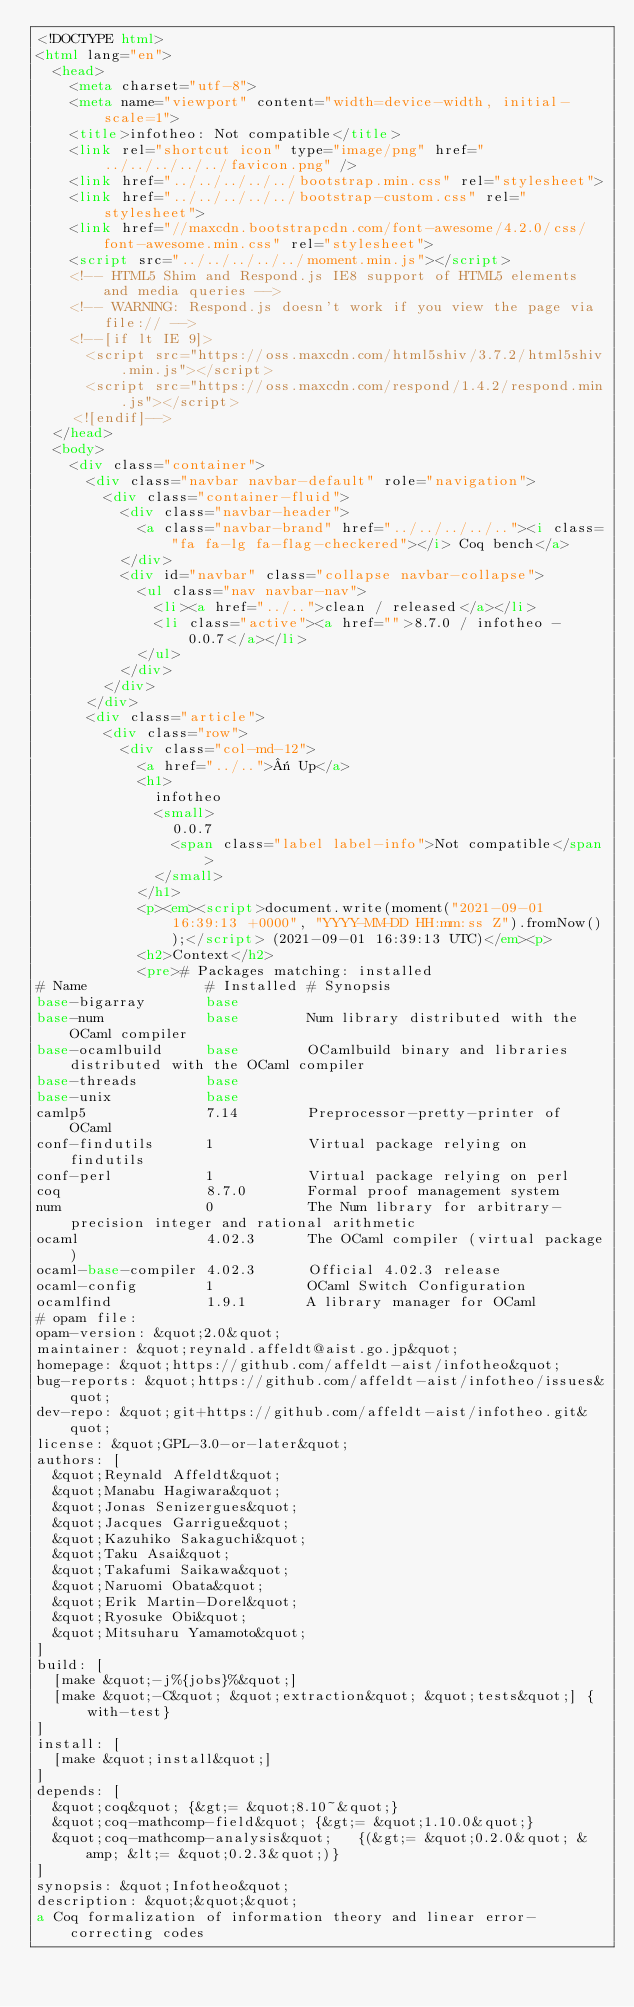<code> <loc_0><loc_0><loc_500><loc_500><_HTML_><!DOCTYPE html>
<html lang="en">
  <head>
    <meta charset="utf-8">
    <meta name="viewport" content="width=device-width, initial-scale=1">
    <title>infotheo: Not compatible</title>
    <link rel="shortcut icon" type="image/png" href="../../../../../favicon.png" />
    <link href="../../../../../bootstrap.min.css" rel="stylesheet">
    <link href="../../../../../bootstrap-custom.css" rel="stylesheet">
    <link href="//maxcdn.bootstrapcdn.com/font-awesome/4.2.0/css/font-awesome.min.css" rel="stylesheet">
    <script src="../../../../../moment.min.js"></script>
    <!-- HTML5 Shim and Respond.js IE8 support of HTML5 elements and media queries -->
    <!-- WARNING: Respond.js doesn't work if you view the page via file:// -->
    <!--[if lt IE 9]>
      <script src="https://oss.maxcdn.com/html5shiv/3.7.2/html5shiv.min.js"></script>
      <script src="https://oss.maxcdn.com/respond/1.4.2/respond.min.js"></script>
    <![endif]-->
  </head>
  <body>
    <div class="container">
      <div class="navbar navbar-default" role="navigation">
        <div class="container-fluid">
          <div class="navbar-header">
            <a class="navbar-brand" href="../../../../.."><i class="fa fa-lg fa-flag-checkered"></i> Coq bench</a>
          </div>
          <div id="navbar" class="collapse navbar-collapse">
            <ul class="nav navbar-nav">
              <li><a href="../..">clean / released</a></li>
              <li class="active"><a href="">8.7.0 / infotheo - 0.0.7</a></li>
            </ul>
          </div>
        </div>
      </div>
      <div class="article">
        <div class="row">
          <div class="col-md-12">
            <a href="../..">« Up</a>
            <h1>
              infotheo
              <small>
                0.0.7
                <span class="label label-info">Not compatible</span>
              </small>
            </h1>
            <p><em><script>document.write(moment("2021-09-01 16:39:13 +0000", "YYYY-MM-DD HH:mm:ss Z").fromNow());</script> (2021-09-01 16:39:13 UTC)</em><p>
            <h2>Context</h2>
            <pre># Packages matching: installed
# Name              # Installed # Synopsis
base-bigarray       base
base-num            base        Num library distributed with the OCaml compiler
base-ocamlbuild     base        OCamlbuild binary and libraries distributed with the OCaml compiler
base-threads        base
base-unix           base
camlp5              7.14        Preprocessor-pretty-printer of OCaml
conf-findutils      1           Virtual package relying on findutils
conf-perl           1           Virtual package relying on perl
coq                 8.7.0       Formal proof management system
num                 0           The Num library for arbitrary-precision integer and rational arithmetic
ocaml               4.02.3      The OCaml compiler (virtual package)
ocaml-base-compiler 4.02.3      Official 4.02.3 release
ocaml-config        1           OCaml Switch Configuration
ocamlfind           1.9.1       A library manager for OCaml
# opam file:
opam-version: &quot;2.0&quot;
maintainer: &quot;reynald.affeldt@aist.go.jp&quot;
homepage: &quot;https://github.com/affeldt-aist/infotheo&quot;
bug-reports: &quot;https://github.com/affeldt-aist/infotheo/issues&quot;
dev-repo: &quot;git+https://github.com/affeldt-aist/infotheo.git&quot;
license: &quot;GPL-3.0-or-later&quot;
authors: [
  &quot;Reynald Affeldt&quot;
  &quot;Manabu Hagiwara&quot;
  &quot;Jonas Senizergues&quot;
  &quot;Jacques Garrigue&quot;
  &quot;Kazuhiko Sakaguchi&quot;
  &quot;Taku Asai&quot;
  &quot;Takafumi Saikawa&quot;
  &quot;Naruomi Obata&quot;
  &quot;Erik Martin-Dorel&quot;
  &quot;Ryosuke Obi&quot;
  &quot;Mitsuharu Yamamoto&quot;
]
build: [
  [make &quot;-j%{jobs}%&quot;]
  [make &quot;-C&quot; &quot;extraction&quot; &quot;tests&quot;] {with-test}
]
install: [
  [make &quot;install&quot;]
]
depends: [
  &quot;coq&quot; {&gt;= &quot;8.10~&quot;}
  &quot;coq-mathcomp-field&quot; {&gt;= &quot;1.10.0&quot;}
  &quot;coq-mathcomp-analysis&quot;   {(&gt;= &quot;0.2.0&quot; &amp; &lt;= &quot;0.2.3&quot;)}
]
synopsis: &quot;Infotheo&quot;
description: &quot;&quot;&quot;
a Coq formalization of information theory and linear error-correcting codes</code> 